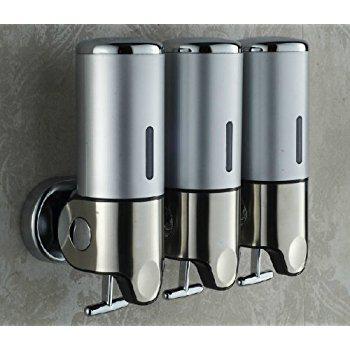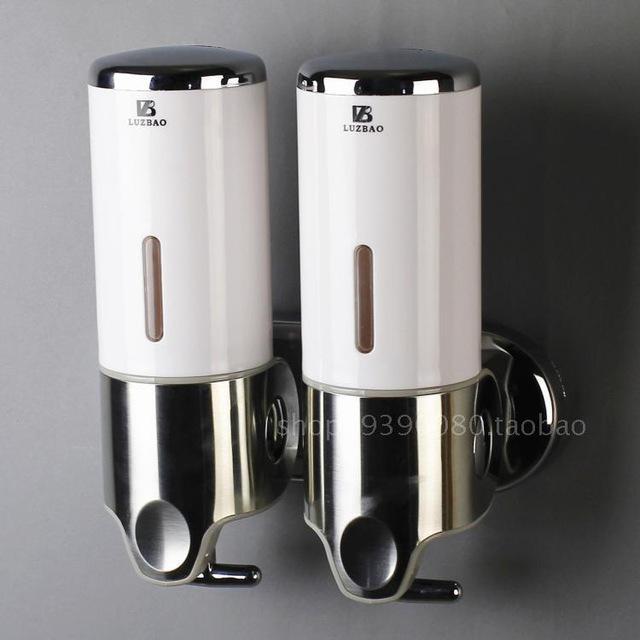The first image is the image on the left, the second image is the image on the right. Evaluate the accuracy of this statement regarding the images: "A three-in-one joined dispenser holds substances of three different colors that show through the transparent top portions.". Is it true? Answer yes or no. No. The first image is the image on the left, the second image is the image on the right. Considering the images on both sides, is "The right hand image shows three dispensers that each have a different color of liquid inside of them." valid? Answer yes or no. No. 